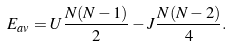Convert formula to latex. <formula><loc_0><loc_0><loc_500><loc_500>E _ { a v } = U \frac { N ( N - 1 ) } { 2 } - J \frac { N ( N - 2 ) } { 4 } .</formula> 